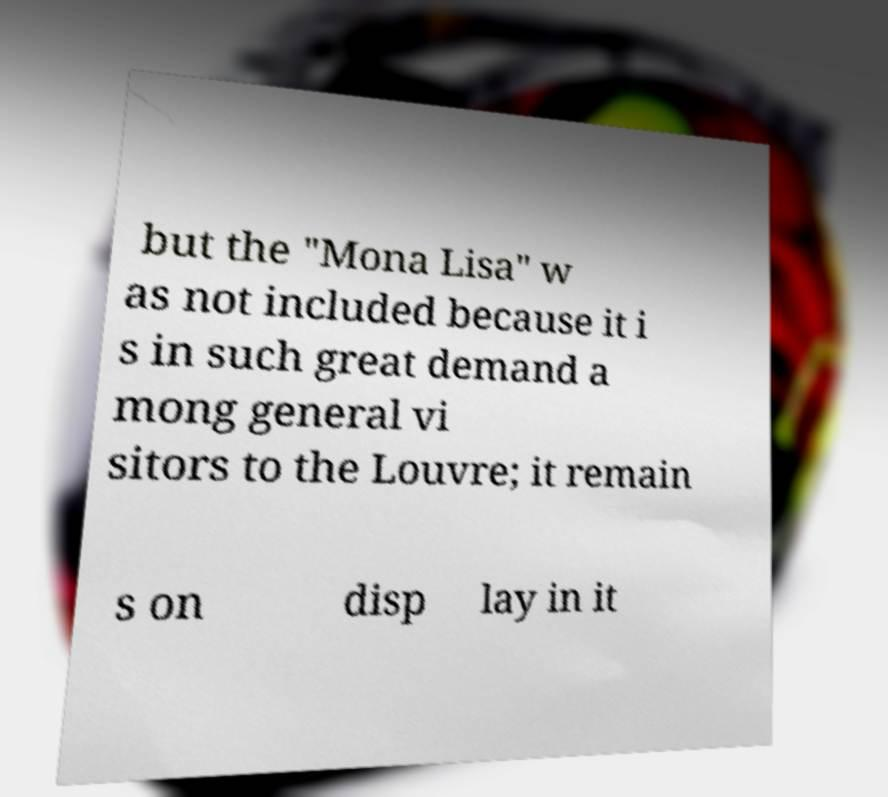There's text embedded in this image that I need extracted. Can you transcribe it verbatim? but the "Mona Lisa" w as not included because it i s in such great demand a mong general vi sitors to the Louvre; it remain s on disp lay in it 